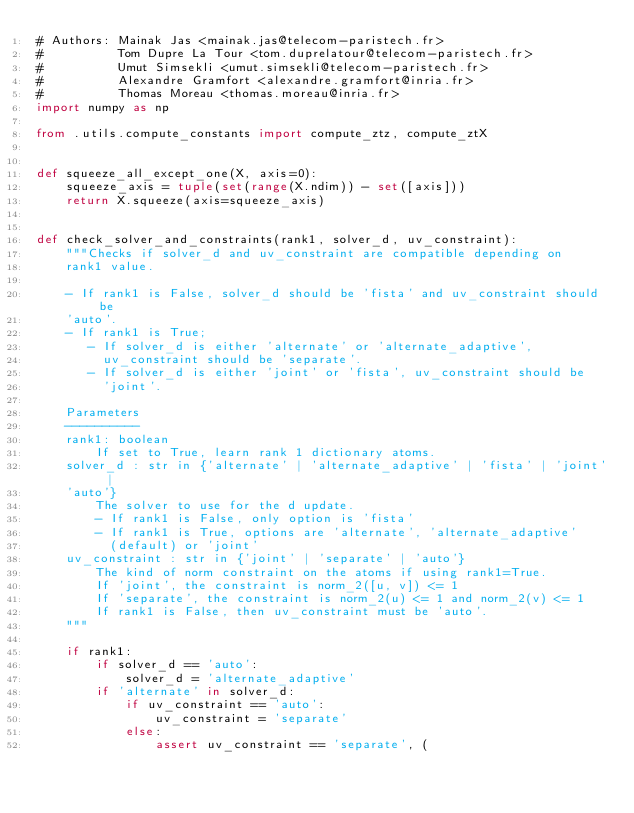Convert code to text. <code><loc_0><loc_0><loc_500><loc_500><_Python_># Authors: Mainak Jas <mainak.jas@telecom-paristech.fr>
#          Tom Dupre La Tour <tom.duprelatour@telecom-paristech.fr>
#          Umut Simsekli <umut.simsekli@telecom-paristech.fr>
#          Alexandre Gramfort <alexandre.gramfort@inria.fr>
#          Thomas Moreau <thomas.moreau@inria.fr>
import numpy as np

from .utils.compute_constants import compute_ztz, compute_ztX


def squeeze_all_except_one(X, axis=0):
    squeeze_axis = tuple(set(range(X.ndim)) - set([axis]))
    return X.squeeze(axis=squeeze_axis)


def check_solver_and_constraints(rank1, solver_d, uv_constraint):
    """Checks if solver_d and uv_constraint are compatible depending on
    rank1 value.

    - If rank1 is False, solver_d should be 'fista' and uv_constraint should be
    'auto'.
    - If rank1 is True;
       - If solver_d is either 'alternate' or 'alternate_adaptive',
         uv_constraint should be 'separate'.
       - If solver_d is either 'joint' or 'fista', uv_constraint should be
         'joint'.

    Parameters
    ----------
    rank1: boolean
        If set to True, learn rank 1 dictionary atoms.
    solver_d : str in {'alternate' | 'alternate_adaptive' | 'fista' | 'joint' |
    'auto'}
        The solver to use for the d update.
        - If rank1 is False, only option is 'fista'
        - If rank1 is True, options are 'alternate', 'alternate_adaptive'
          (default) or 'joint'
    uv_constraint : str in {'joint' | 'separate' | 'auto'}
        The kind of norm constraint on the atoms if using rank1=True.
        If 'joint', the constraint is norm_2([u, v]) <= 1
        If 'separate', the constraint is norm_2(u) <= 1 and norm_2(v) <= 1
        If rank1 is False, then uv_constraint must be 'auto'.
    """

    if rank1:
        if solver_d == 'auto':
            solver_d = 'alternate_adaptive'
        if 'alternate' in solver_d:
            if uv_constraint == 'auto':
                uv_constraint = 'separate'
            else:
                assert uv_constraint == 'separate', (</code> 